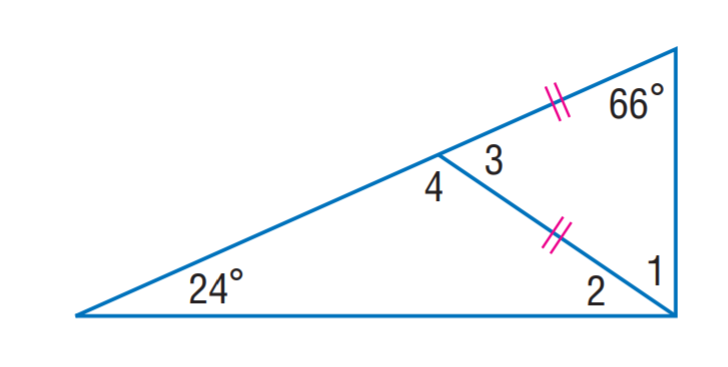Answer the mathemtical geometry problem and directly provide the correct option letter.
Question: Find m \angle 2.
Choices: A: 12 B: 24 C: 38 D: 66 B 